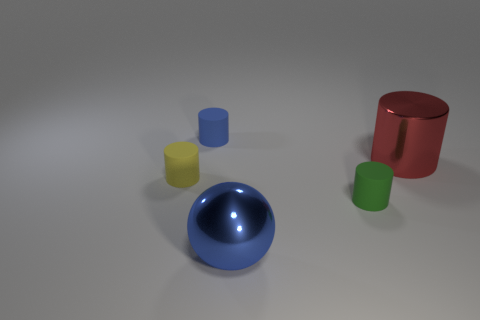How do the textures of these objects differ? The red and green objects have a matte finish, which diffuses light and gives them a soft appearance. The blue sphere, however, has a high gloss texture that reflects light strongly, creating a shiny and smooth surface. Can you describe the lighting in this image? The lighting in the image is soft and diffused, with what appears to be a single light source from above, casting gentle shadows beneath the objects. The blue sphere reflects the light source, indicating its glossy texture. 